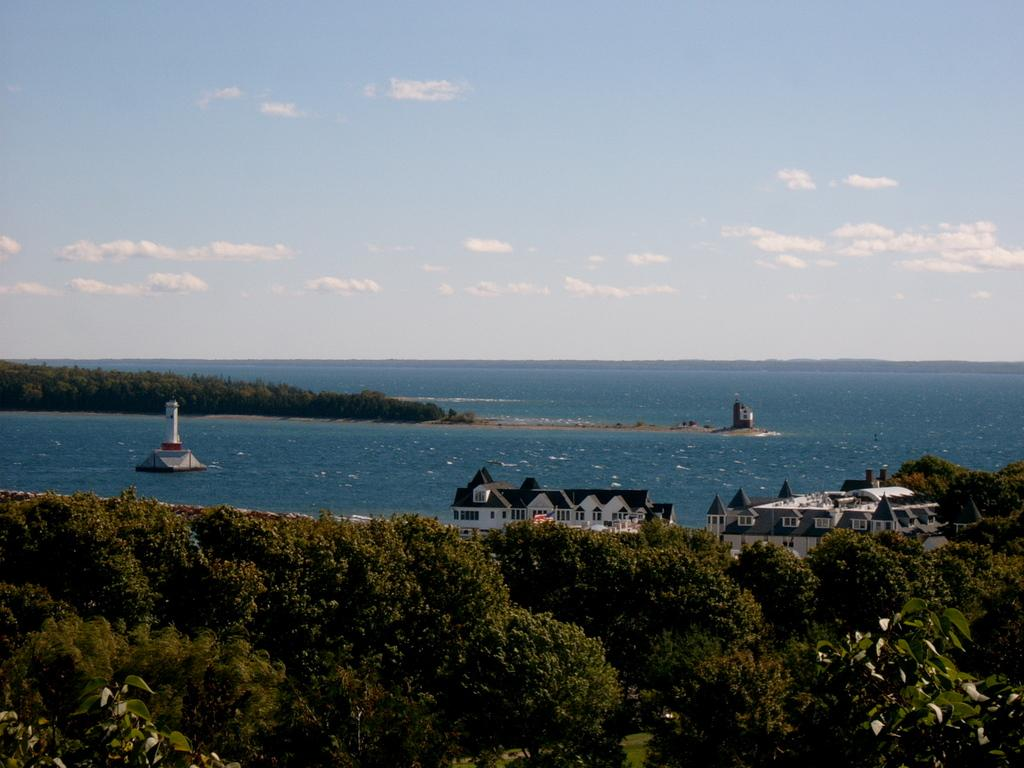What type of natural elements can be seen in the image? There are trees in the image. What type of man-made structures can be seen in the image? There are houses and a lighthouse in the image. Where is the lighthouse located in relation to the other elements in the image? The lighthouse is located on the water. What type of tramp can be seen jumping over the river in the image? There is no tramp or river present in the image. 